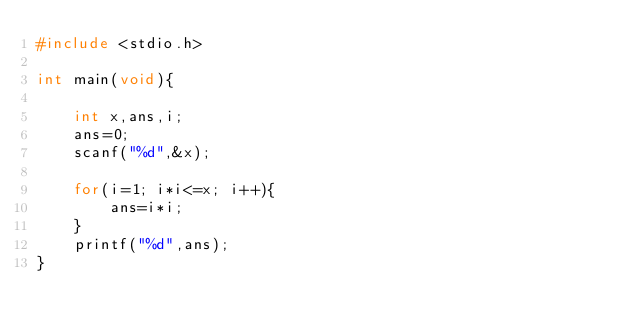Convert code to text. <code><loc_0><loc_0><loc_500><loc_500><_C_>#include <stdio.h>

int main(void){
    
    int x,ans,i;
    ans=0;
    scanf("%d",&x);
    
    for(i=1; i*i<=x; i++){
        ans=i*i;
    }
    printf("%d",ans);
}</code> 